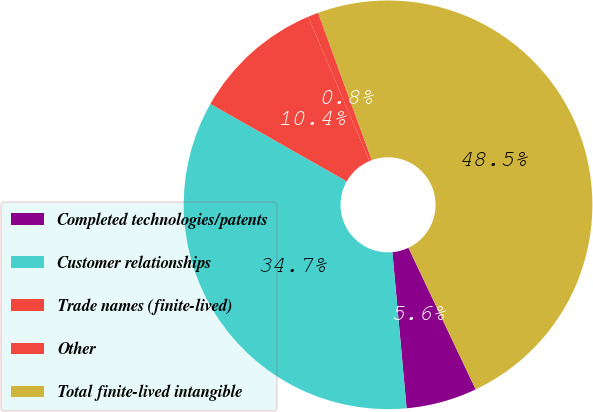Convert chart. <chart><loc_0><loc_0><loc_500><loc_500><pie_chart><fcel>Completed technologies/patents<fcel>Customer relationships<fcel>Trade names (finite-lived)<fcel>Other<fcel>Total finite-lived intangible<nl><fcel>5.61%<fcel>34.67%<fcel>10.38%<fcel>0.84%<fcel>48.5%<nl></chart> 